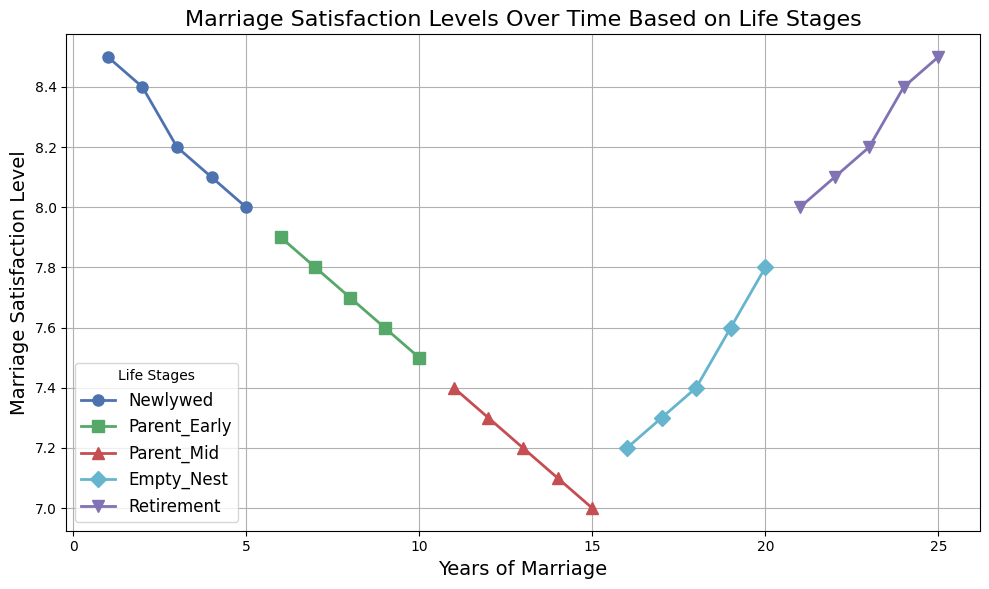How does marriage satisfaction change from the Newlywed stage to the Parent Early stage? To evaluate the change, we look at the end point of the Newlywed stage (5 years, satisfaction level 8.0) and the starting point of the Parent Early stage (6 years, satisfaction level 7.9). The decrease in satisfaction level is 8.0 - 7.9 = 0.1.
Answer: Decreases by 0.1 Which life stage shows the greatest increase in marriage satisfaction levels over time? By examining the slopes of the lines for each life stage, we notice that the Retirement stage starts at 21 years (satisfaction level 8.0) and ends at 25 years (satisfaction level 8.5), with an increase of 0.5 in satisfaction level. This increase is greater than any other stage.
Answer: Retirement What is the average marriage satisfaction level during the Newlywed stage? There are 5 data points for the Newlywed stage (8.5, 8.4, 8.2, 8.1, 8.0). Summing these values gives 41.2, and the average is 41.2 / 5 = 8.24.
Answer: 8.24 How does the marriage satisfaction level at the 10th year compare to that at the 20th year? At the 10th year, the satisfaction level is 7.5 (Parent Early stage), and at the 20th year, it is 7.8 (Empty Nest stage). Thus, 7.8 - 7.5 = 0.3, and the satisfaction level increases by 0.3.
Answer: Increases by 0.3 In which life stage does the marriage satisfaction level begin to increase after a period of decline? The satisfaction level begins to increase in the Empty Nest stage starting from 16 years (7.2) and continues to increase until the 20th year (7.8) after declining through the Parent Mid stage.
Answer: Empty Nest What is the overall trend in marriage satisfaction levels from the Parent Mid stage to the Retirement stage? During the Parent Mid stage (7.4 to 7.0) satisfaction levels decline, but from the Empty Nest stage onwards (7.2 to 8.5) there is a general increasing trend.
Answer: Decreases then increases In which year does marriage satisfaction level start to rise after reaching its lowest point? The lowest point of satisfaction (7.0) is reached in the 15th year (Parent Mid stage) and begins to rise in the 16th year (Empty Nest stage).
Answer: 16th year What's the difference in marriage satisfaction levels between the start and end of the Empty Nest stage? At the start of the Empty Nest stage (16 years), satisfaction is 7.2, and at the end (20 years), it is 7.8. The difference is 7.8 - 7.2 = 0.6.
Answer: 0.6 In terms of visual attributes, which life stage is represented by the green line? From the details of the code, we know the order of colors and our map shows that the second color (green) aligns with the Parent Early stage.
Answer: Parent Early How much does marriage satisfaction improve during the Retirement stage? At the beginning of the Retirement stage, the rating is 8.0 (21 years), and at the end, it is 8.5 (25 years). The improvement is 8.5 - 8.0 = 0.5.
Answer: 0.5 